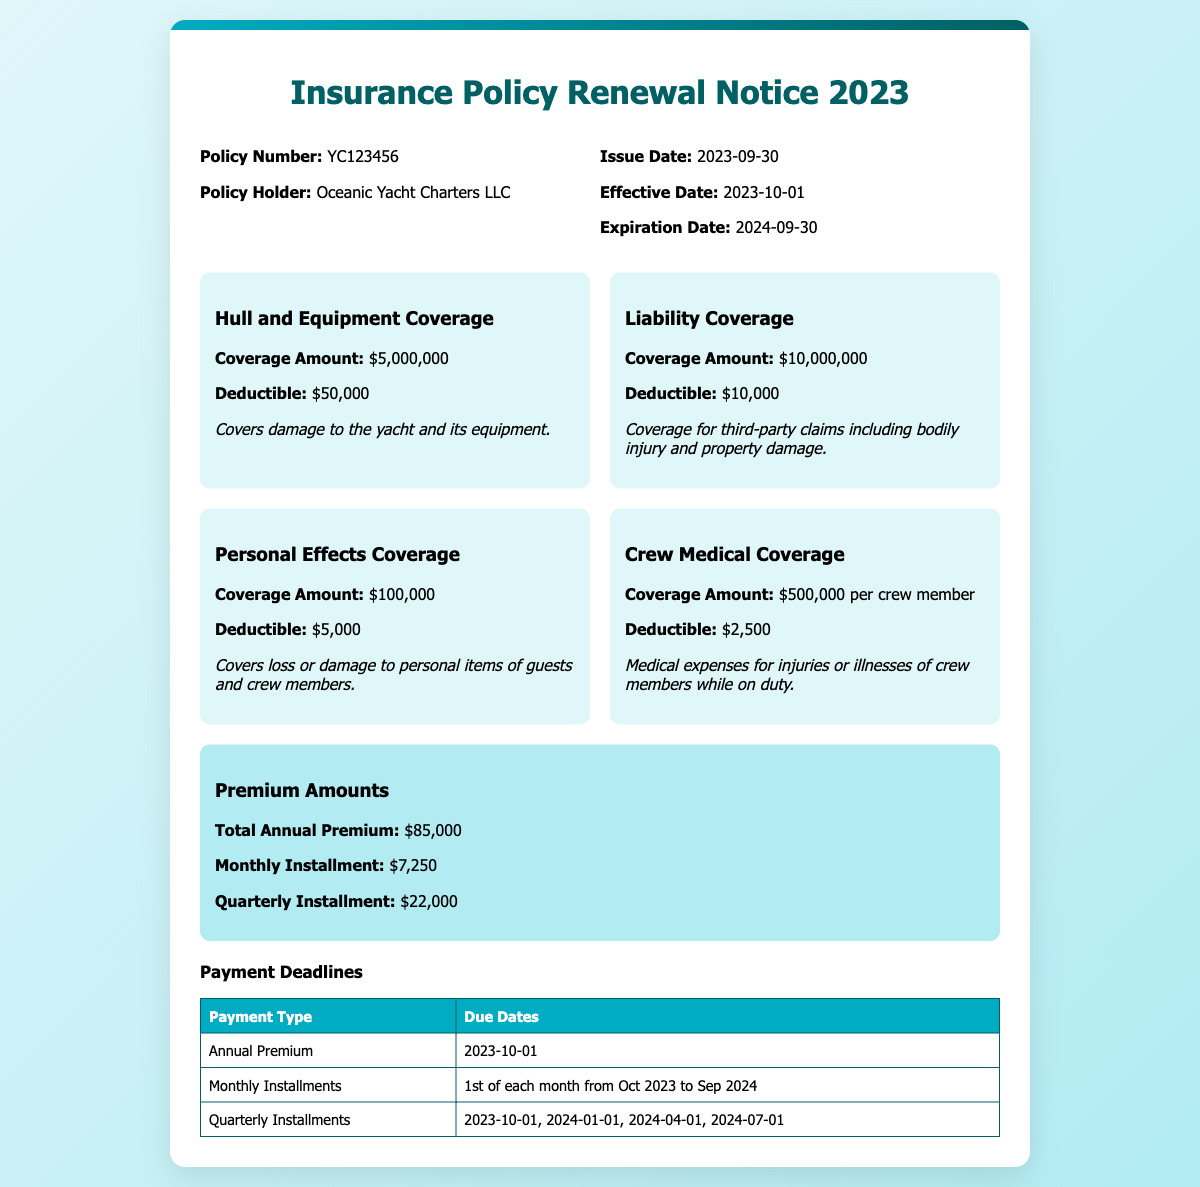What is the policy number? The policy number is clearly stated in the document under Policy Info section.
Answer: YC123456 What is the total annual premium? The total annual premium is listed under the premium information section of the document.
Answer: $85,000 What is the effective date of the policy? The effective date is provided in the policy info section of the document.
Answer: 2023-10-01 How much is the deductible for hull and equipment coverage? The deductible for hull and equipment coverage can be found in the coverage details section.
Answer: $50,000 When is the due date for the annual premium? The due date for the annual premium is specified in the payment deadlines table of the document.
Answer: 2023-10-01 What is the coverage amount for liability coverage? The coverage amount for liability coverage is mentioned in the coverage details section.
Answer: $10,000,000 How often are monthly installments due? The frequency of monthly installment payments is outlined in the payment deadlines table.
Answer: 1st of each month Which company holds the policy? The policy holder's name is provided in the policy info section of the document.
Answer: Oceanic Yacht Charters LLC What deductible applies to crew medical coverage? The deductible for crew medical coverage is listed in the coverage details section of the document.
Answer: $2,500 